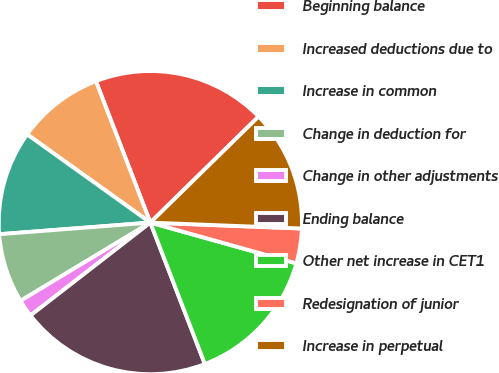<chart> <loc_0><loc_0><loc_500><loc_500><pie_chart><fcel>Beginning balance<fcel>Increased deductions due to<fcel>Increase in common<fcel>Change in deduction for<fcel>Change in other adjustments<fcel>Ending balance<fcel>Other net increase in CET1<fcel>Redesignation of junior<fcel>Increase in perpetual<nl><fcel>18.51%<fcel>9.26%<fcel>11.11%<fcel>7.41%<fcel>1.86%<fcel>20.36%<fcel>14.81%<fcel>3.71%<fcel>12.96%<nl></chart> 